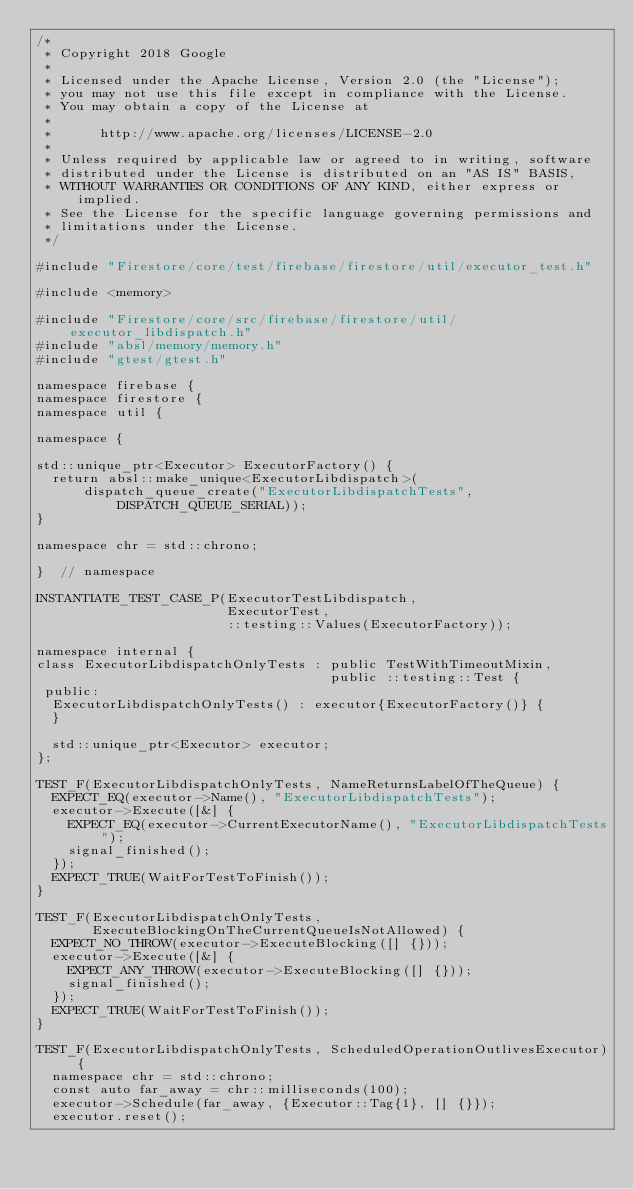<code> <loc_0><loc_0><loc_500><loc_500><_ObjectiveC_>/*
 * Copyright 2018 Google
 *
 * Licensed under the Apache License, Version 2.0 (the "License");
 * you may not use this file except in compliance with the License.
 * You may obtain a copy of the License at
 *
 *      http://www.apache.org/licenses/LICENSE-2.0
 *
 * Unless required by applicable law or agreed to in writing, software
 * distributed under the License is distributed on an "AS IS" BASIS,
 * WITHOUT WARRANTIES OR CONDITIONS OF ANY KIND, either express or implied.
 * See the License for the specific language governing permissions and
 * limitations under the License.
 */

#include "Firestore/core/test/firebase/firestore/util/executor_test.h"

#include <memory>

#include "Firestore/core/src/firebase/firestore/util/executor_libdispatch.h"
#include "absl/memory/memory.h"
#include "gtest/gtest.h"

namespace firebase {
namespace firestore {
namespace util {

namespace {

std::unique_ptr<Executor> ExecutorFactory() {
  return absl::make_unique<ExecutorLibdispatch>(
      dispatch_queue_create("ExecutorLibdispatchTests", DISPATCH_QUEUE_SERIAL));
}

namespace chr = std::chrono;

}  // namespace

INSTANTIATE_TEST_CASE_P(ExecutorTestLibdispatch,
                        ExecutorTest,
                        ::testing::Values(ExecutorFactory));

namespace internal {
class ExecutorLibdispatchOnlyTests : public TestWithTimeoutMixin,
                                     public ::testing::Test {
 public:
  ExecutorLibdispatchOnlyTests() : executor{ExecutorFactory()} {
  }

  std::unique_ptr<Executor> executor;
};

TEST_F(ExecutorLibdispatchOnlyTests, NameReturnsLabelOfTheQueue) {
  EXPECT_EQ(executor->Name(), "ExecutorLibdispatchTests");
  executor->Execute([&] {
    EXPECT_EQ(executor->CurrentExecutorName(), "ExecutorLibdispatchTests");
    signal_finished();
  });
  EXPECT_TRUE(WaitForTestToFinish());
}

TEST_F(ExecutorLibdispatchOnlyTests,
       ExecuteBlockingOnTheCurrentQueueIsNotAllowed) {
  EXPECT_NO_THROW(executor->ExecuteBlocking([] {}));
  executor->Execute([&] {
    EXPECT_ANY_THROW(executor->ExecuteBlocking([] {}));
    signal_finished();
  });
  EXPECT_TRUE(WaitForTestToFinish());
}

TEST_F(ExecutorLibdispatchOnlyTests, ScheduledOperationOutlivesExecutor) {
  namespace chr = std::chrono;
  const auto far_away = chr::milliseconds(100);
  executor->Schedule(far_away, {Executor::Tag{1}, [] {}});
  executor.reset();</code> 